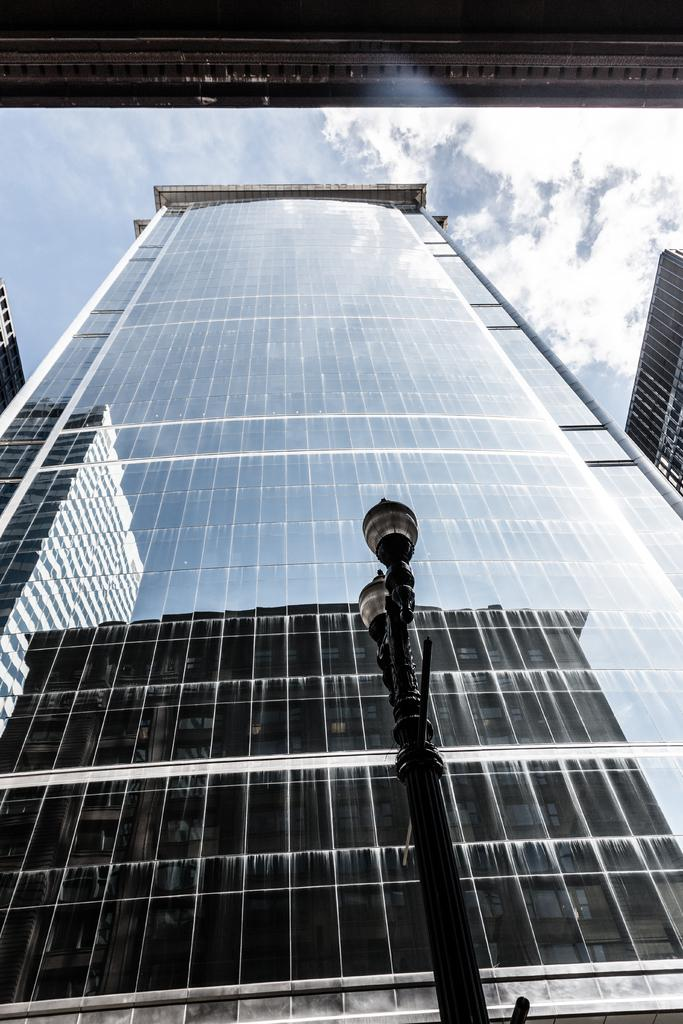What type of structure is present in the image? There is a building in the image. What can be seen on the right side of the image? There is a pole on the right side of the image. What is visible in the background of the image? The sky is visible in the background of the image. What is the back of the building made of in the image? The provided facts do not mention the material of the building's back, so it cannot be determined from the image. 